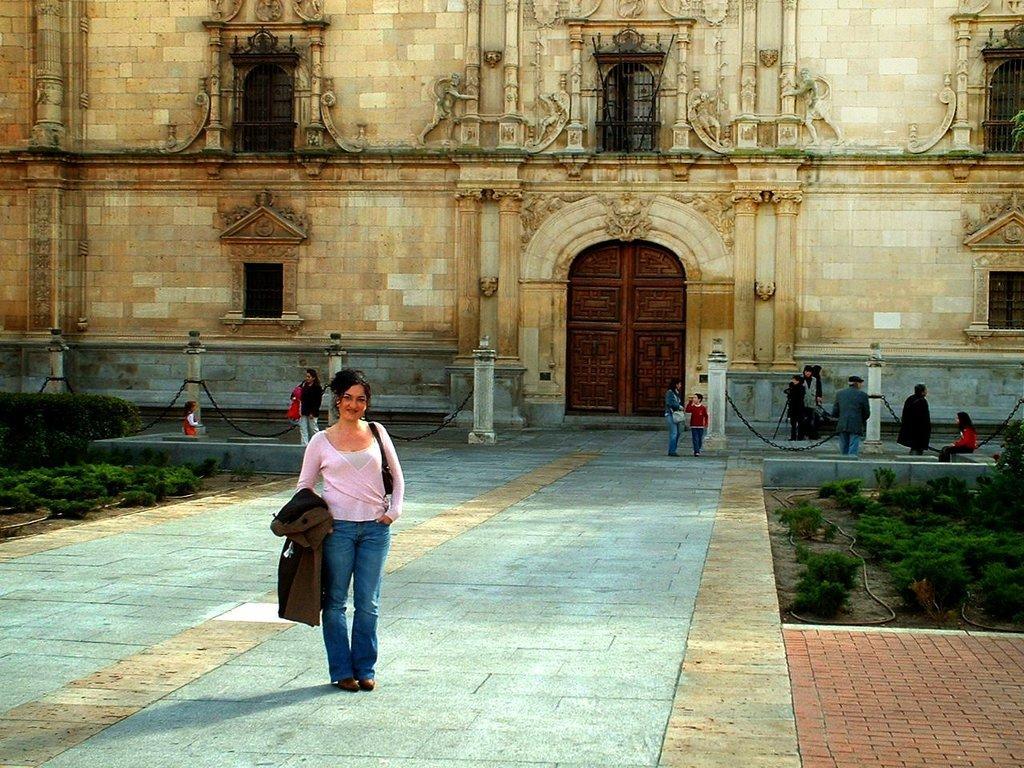Can you describe this image briefly? In this image we can see a person wearing pink color dress holding brown color jacket in her hands standing on the ground and in the background of the image there are some persons standing and some are sitting near the building there are some plants, there is building which is of brown color, there are some windows and main door is of brown color, there is fencing. 